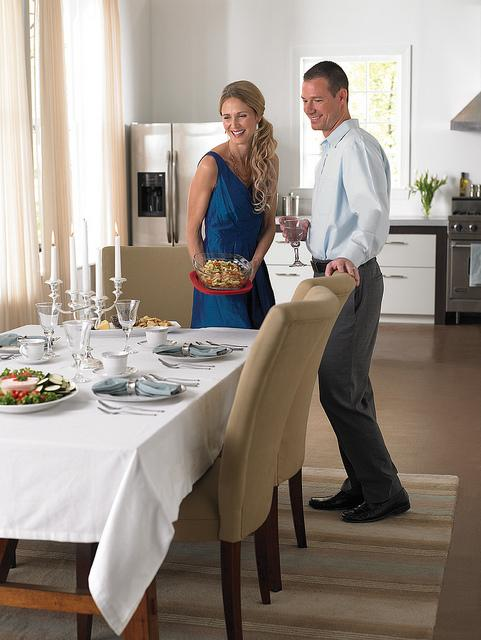What is the name of dining candles?

Choices:
A) tea light
B) votives
C) taper candles
D) pillar candles votives 